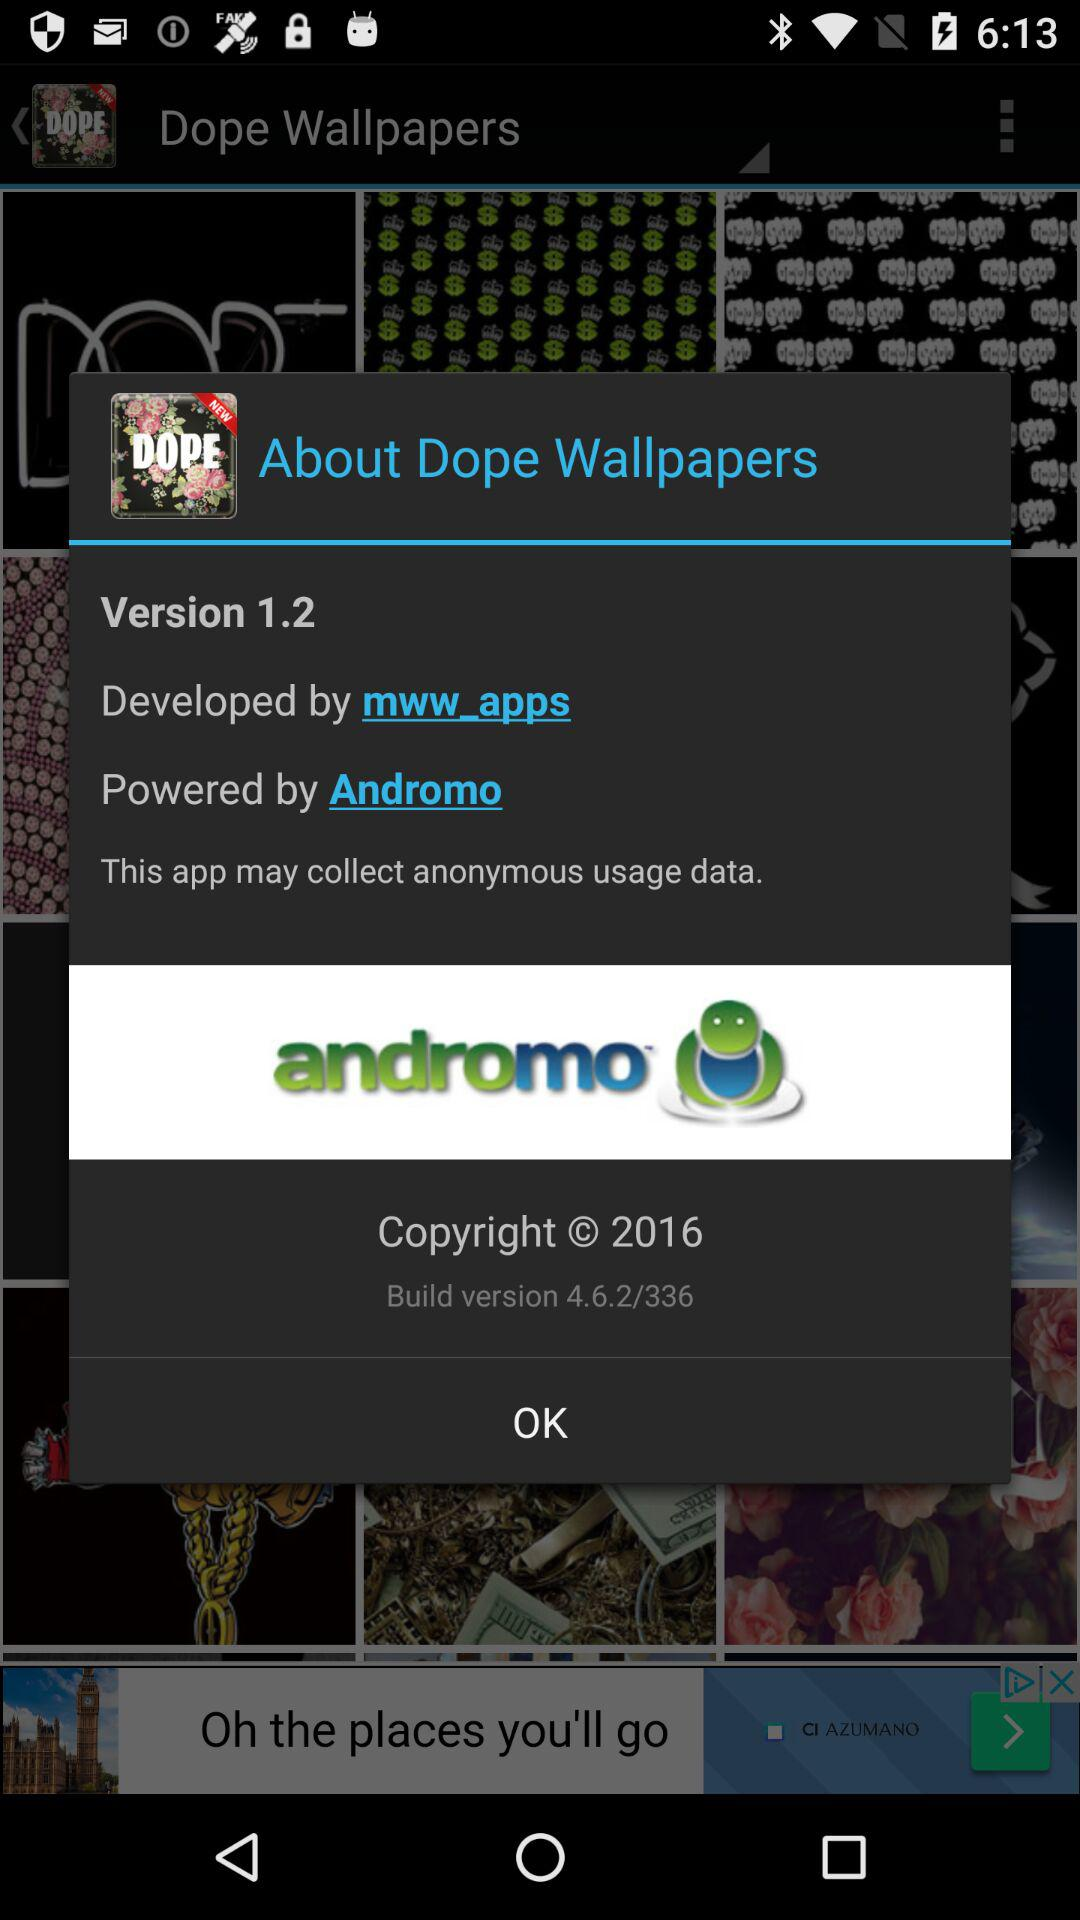What is the name of the application? The name of the application is "Dope Wallpapers". 